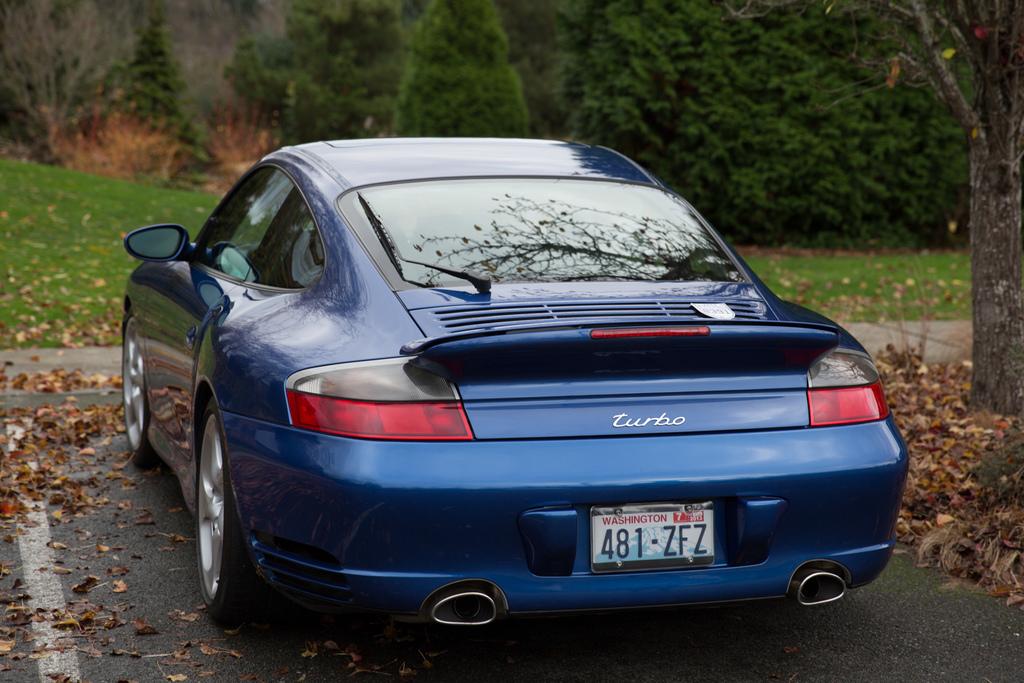What kind of porsche is this?
Provide a succinct answer. Turbo. 